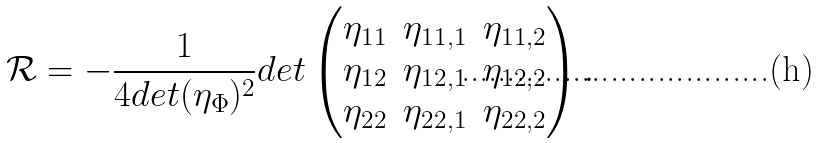<formula> <loc_0><loc_0><loc_500><loc_500>\mathcal { R } = - \frac { 1 } { 4 d e t ( \eta _ { \Phi } ) ^ { 2 } } d e t \begin{pmatrix} \eta _ { 1 1 } & \eta _ { 1 1 , 1 } & \eta _ { 1 1 , 2 } \\ \eta _ { 1 2 } & \eta _ { 1 2 , 1 } & \eta _ { 1 2 , 2 } \\ \eta _ { 2 2 } & \eta _ { 2 2 , 1 } & \eta _ { 2 2 , 2 } \\ \end{pmatrix} .</formula> 